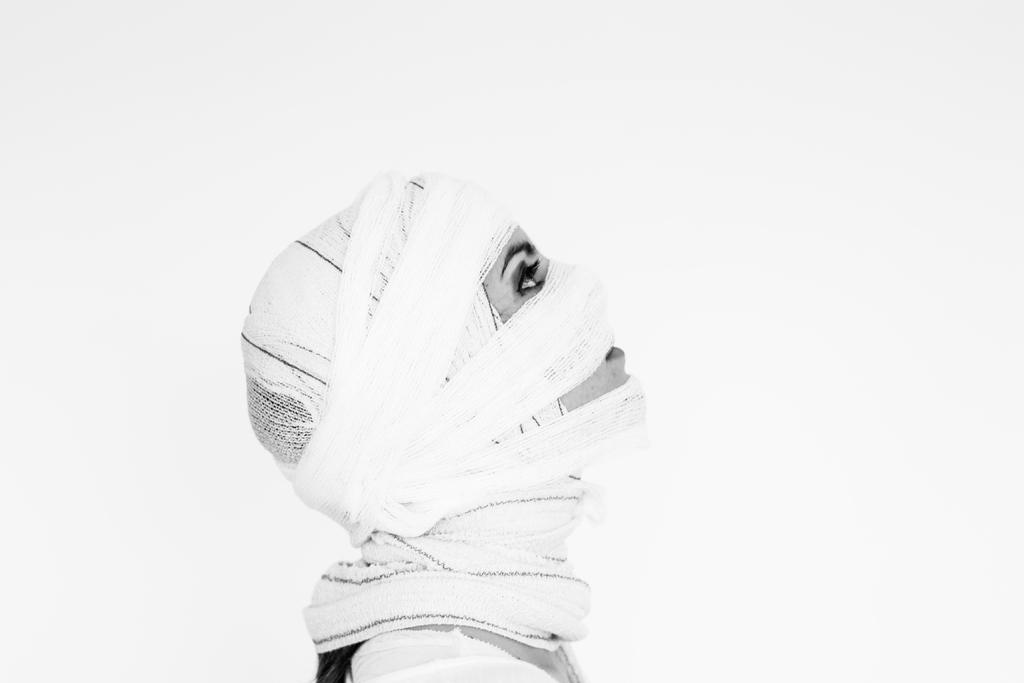Who is the main subject in the image? There is a woman in the image. What is the woman wearing on her head? The woman is wearing a white headscarf. What color is the woman's dress? The woman is wearing a white dress. What is the color of the background in the image? The background of the image is white in color. What type of book is the woman holding in the image? There is no book present in the image; the woman is not holding anything. 